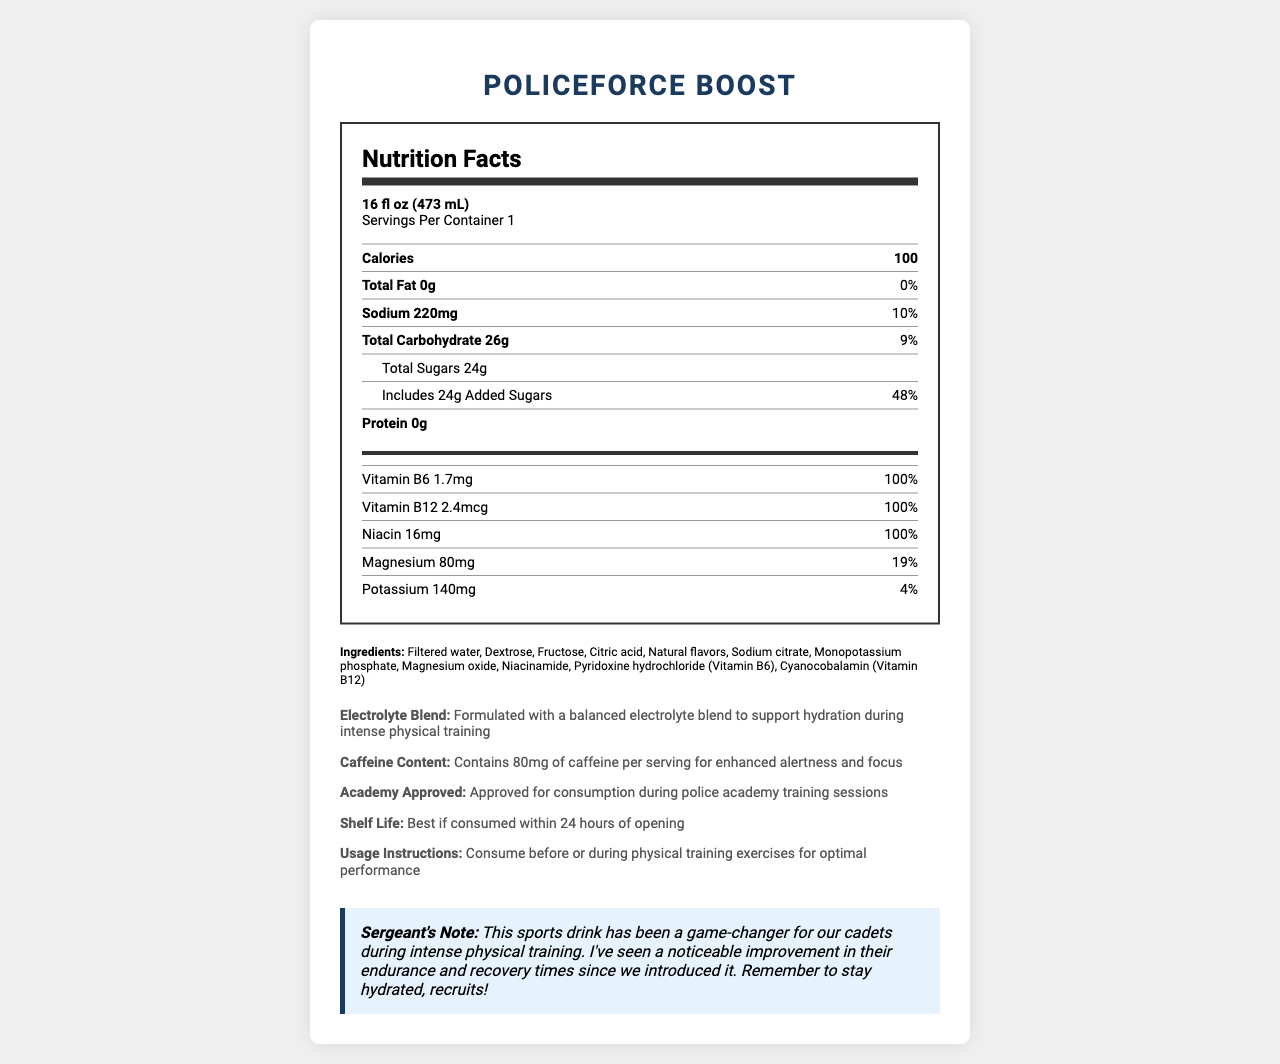What is the serving size of PoliceForce Boost? The serving size is listed at the top of the nutrition facts under "Serving Size".
Answer: 16 fl oz (473 mL) How many calories are in one serving of PoliceForce Boost? The number of calories is prominently listed in bold in the first nutrient row.
Answer: 100 What is the sodium content per serving? The sodium content is listed in the nutrient rows, with 220mg being the amount.
Answer: 220mg Which vitamin has the highest daily value percentage in PoliceForce Boost? Each of these vitamins has a daily value of 100%, as indicated in the vitamins section.
Answer: Vitamin B6, Vitamin B12, and Niacin (each 100%) What is the total carbohydrate amount in one serving of PoliceForce Boost? The total carbohydrate amount is listed in the nutrient rows.
Answer: 26g How much added sugar is in one serving? The amount of added sugars is detailed in the sub-nutrient row under Total Sugars, reflecting 24g.
Answer: 24g What is the caffeine content per serving? A. 50mg B. 60mg C. 80mg D. 100mg The document mentions "Contains 80mg of caffeine per serving for enhanced alertness and focus" in the additional information section.
Answer: C. 80mg What percentage of the daily value of magnesium does one serving of PoliceForce Boost provide? A. 10% B. 19% C. 25% D. 50% The magnesium content provides 19% of the daily value, as indicated in the vitamins section.
Answer: B. 19% Is PoliceForce Boost approved for consumption during police academy training sessions? The document confirms this with the note "Approved for consumption during police academy training sessions."
Answer: Yes Summarize the main purpose and contents of the document. The document combines nutritional content, a list of ingredients, a sergeant's note on its effectiveness, and supplementary details like caffeine content and approval for use during training.
Answer: The document provides the nutrition facts and additional information for PoliceForce Boost, a fortified sports drink aimed at improving physical performance during police academy training. It details serving size, calorie content, macronutrients, vitamins and minerals, ingredients, and other notable attributes about the product designed to enhance endurance and recovery. What is the main benefit of the electrolyte blend mentioned in the additional info? The additional info section states that the electrolyte blend is formulated to support hydration during intense physical training.
Answer: Supports hydration during intense physical training How many grams of protein are in one serving of PoliceForce Boost? The protein content is listed in the nutrient rows, indicating 0g of protein.
Answer: 0g List one of the ingredients that also serves as a vitamin. Niacinamide appears in the ingredients list and is also listed as Niacin in the vitamins section.
Answer: Niacinamide What observable effect has the sergeant noticed since introducing the drink to cadets? The sergeant's note states that there's been a noticeable improvement in cadets' endurance and recovery times since introducing the drink.
Answer: Improvement in endurance and recovery times What is the main carbohydrate source listed in the ingredients? Dextrose and Fructose are the main carbohydrate sources listed in the ingredients section.
Answer: Dextrose and Fructose What is the recommended usage time for consuming PoliceForce Boost for optimal performance? The usage instructions in the additional info suggest consuming the drink before or during physical training exercises for optimal performance.
Answer: Before or during physical training exercises Does the document provide information about the manufacturing location of PoliceForce Boost? The document does not mention anything about the manufacturing location of PoliceForce Boost.
Answer: Not enough information 